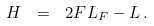Convert formula to latex. <formula><loc_0><loc_0><loc_500><loc_500>H \ = \ 2 F L _ { F } - L \, .</formula> 